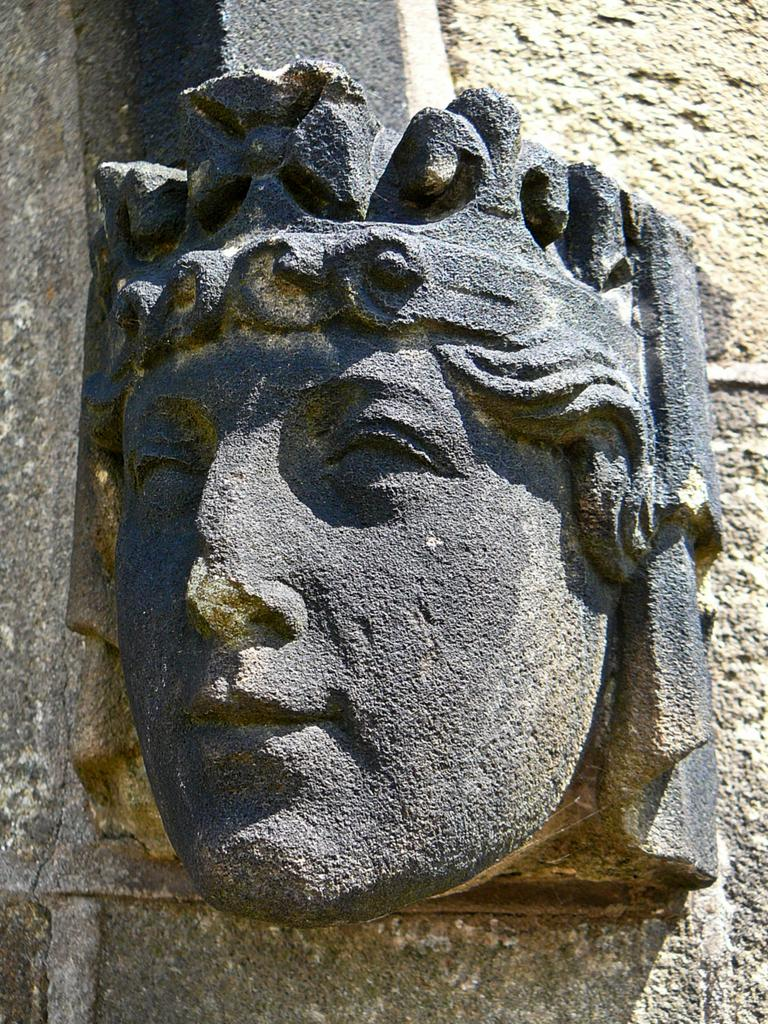What is depicted on the stone wall in the image? There is a carving of a human face on the stone wall in the image. How long has the beginner been practicing their carving skills in the alley? A: There is no beginner or alley present in the image; it features a carving of a human face on a stone wall. 